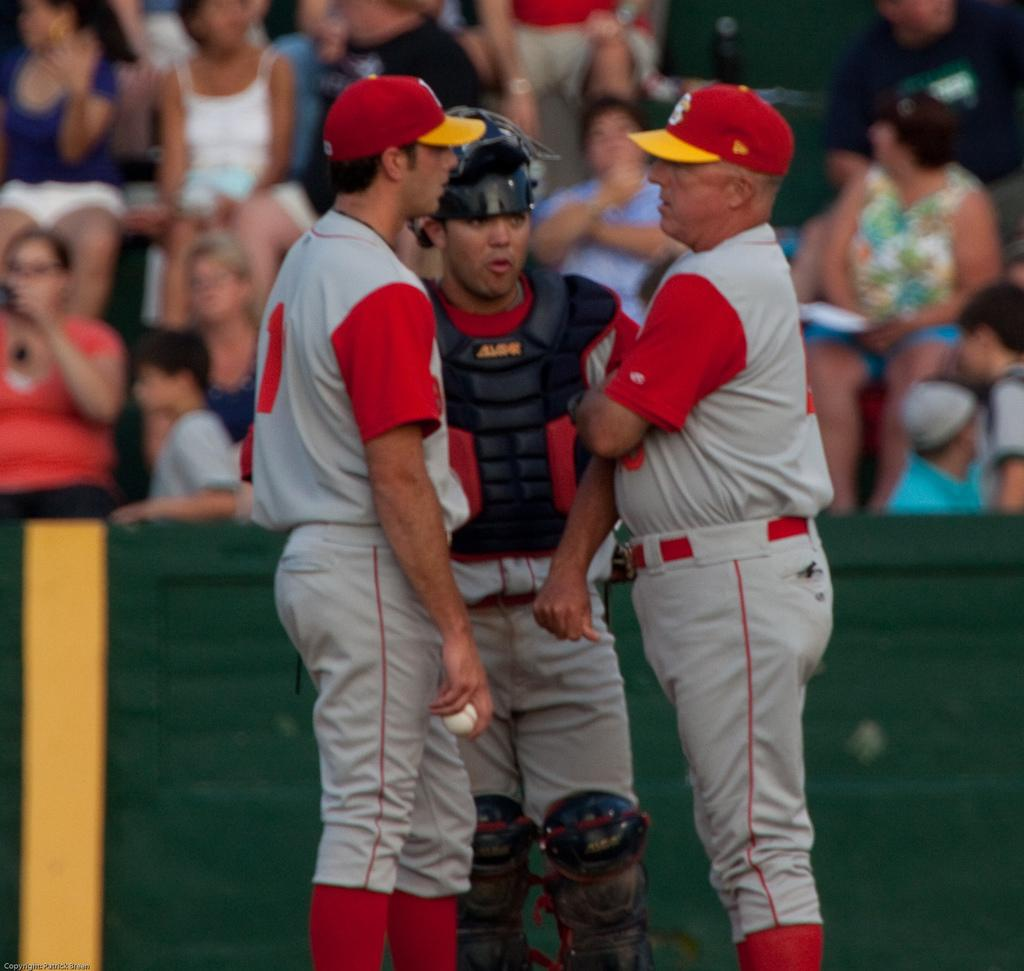What are the people in the image doing? The people in the image are standing and talking. Can you describe any objects being held by the people? One person is holding a ball. What are the people in the background doing? The people in the background are sitting and watching. How many snails can be seen crawling on the lumber in the image? There are no snails or lumber present in the image. What kind of trouble are the people in the image facing? There is no indication of trouble or any specific problem in the image. 